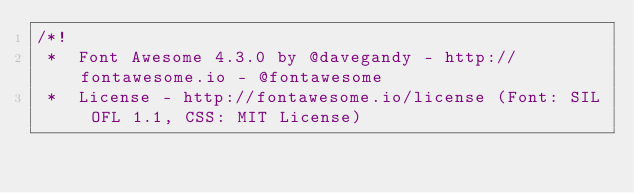<code> <loc_0><loc_0><loc_500><loc_500><_CSS_>/*!
 *  Font Awesome 4.3.0 by @davegandy - http://fontawesome.io - @fontawesome
 *  License - http://fontawesome.io/license (Font: SIL OFL 1.1, CSS: MIT License)</code> 